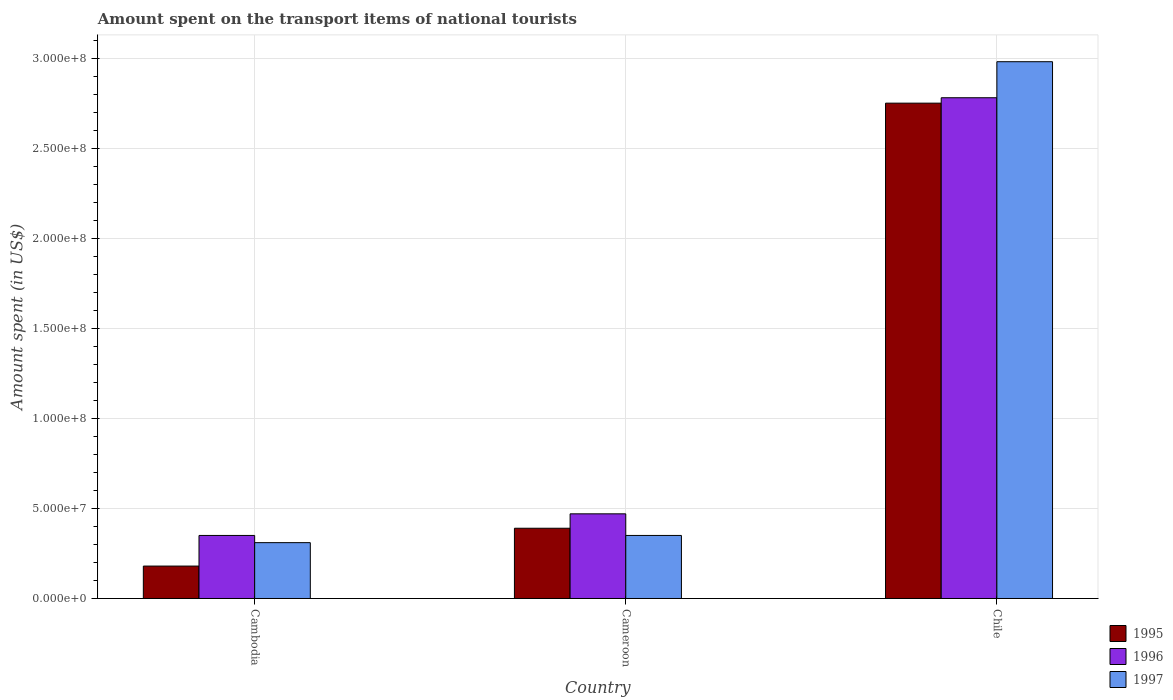How many groups of bars are there?
Offer a terse response. 3. How many bars are there on the 2nd tick from the left?
Offer a very short reply. 3. How many bars are there on the 2nd tick from the right?
Your answer should be very brief. 3. What is the label of the 3rd group of bars from the left?
Ensure brevity in your answer.  Chile. What is the amount spent on the transport items of national tourists in 1996 in Cambodia?
Give a very brief answer. 3.50e+07. Across all countries, what is the maximum amount spent on the transport items of national tourists in 1996?
Your response must be concise. 2.78e+08. Across all countries, what is the minimum amount spent on the transport items of national tourists in 1997?
Make the answer very short. 3.10e+07. In which country was the amount spent on the transport items of national tourists in 1997 minimum?
Provide a succinct answer. Cambodia. What is the total amount spent on the transport items of national tourists in 1997 in the graph?
Make the answer very short. 3.64e+08. What is the difference between the amount spent on the transport items of national tourists in 1997 in Cambodia and that in Chile?
Give a very brief answer. -2.67e+08. What is the difference between the amount spent on the transport items of national tourists in 1996 in Chile and the amount spent on the transport items of national tourists in 1997 in Cameroon?
Your answer should be very brief. 2.43e+08. What is the average amount spent on the transport items of national tourists in 1996 per country?
Keep it short and to the point. 1.20e+08. What is the difference between the amount spent on the transport items of national tourists of/in 1996 and amount spent on the transport items of national tourists of/in 1997 in Chile?
Your response must be concise. -2.00e+07. In how many countries, is the amount spent on the transport items of national tourists in 1996 greater than 110000000 US$?
Offer a terse response. 1. What is the ratio of the amount spent on the transport items of national tourists in 1996 in Cambodia to that in Chile?
Offer a very short reply. 0.13. Is the difference between the amount spent on the transport items of national tourists in 1996 in Cameroon and Chile greater than the difference between the amount spent on the transport items of national tourists in 1997 in Cameroon and Chile?
Your answer should be compact. Yes. What is the difference between the highest and the second highest amount spent on the transport items of national tourists in 1995?
Your answer should be compact. 2.57e+08. What is the difference between the highest and the lowest amount spent on the transport items of national tourists in 1995?
Your answer should be very brief. 2.57e+08. Is the sum of the amount spent on the transport items of national tourists in 1997 in Cambodia and Cameroon greater than the maximum amount spent on the transport items of national tourists in 1995 across all countries?
Provide a short and direct response. No. What does the 3rd bar from the right in Chile represents?
Give a very brief answer. 1995. Is it the case that in every country, the sum of the amount spent on the transport items of national tourists in 1996 and amount spent on the transport items of national tourists in 1995 is greater than the amount spent on the transport items of national tourists in 1997?
Provide a short and direct response. Yes. How many bars are there?
Give a very brief answer. 9. Are all the bars in the graph horizontal?
Provide a succinct answer. No. How many countries are there in the graph?
Offer a terse response. 3. What is the difference between two consecutive major ticks on the Y-axis?
Provide a short and direct response. 5.00e+07. Does the graph contain any zero values?
Your response must be concise. No. How many legend labels are there?
Your answer should be compact. 3. What is the title of the graph?
Your answer should be compact. Amount spent on the transport items of national tourists. What is the label or title of the Y-axis?
Offer a terse response. Amount spent (in US$). What is the Amount spent (in US$) in 1995 in Cambodia?
Offer a terse response. 1.80e+07. What is the Amount spent (in US$) in 1996 in Cambodia?
Provide a succinct answer. 3.50e+07. What is the Amount spent (in US$) of 1997 in Cambodia?
Give a very brief answer. 3.10e+07. What is the Amount spent (in US$) in 1995 in Cameroon?
Offer a terse response. 3.90e+07. What is the Amount spent (in US$) in 1996 in Cameroon?
Ensure brevity in your answer.  4.70e+07. What is the Amount spent (in US$) of 1997 in Cameroon?
Your answer should be compact. 3.50e+07. What is the Amount spent (in US$) in 1995 in Chile?
Provide a short and direct response. 2.75e+08. What is the Amount spent (in US$) of 1996 in Chile?
Your answer should be compact. 2.78e+08. What is the Amount spent (in US$) of 1997 in Chile?
Provide a short and direct response. 2.98e+08. Across all countries, what is the maximum Amount spent (in US$) of 1995?
Ensure brevity in your answer.  2.75e+08. Across all countries, what is the maximum Amount spent (in US$) of 1996?
Provide a succinct answer. 2.78e+08. Across all countries, what is the maximum Amount spent (in US$) in 1997?
Offer a very short reply. 2.98e+08. Across all countries, what is the minimum Amount spent (in US$) in 1995?
Your answer should be compact. 1.80e+07. Across all countries, what is the minimum Amount spent (in US$) in 1996?
Give a very brief answer. 3.50e+07. Across all countries, what is the minimum Amount spent (in US$) of 1997?
Offer a very short reply. 3.10e+07. What is the total Amount spent (in US$) in 1995 in the graph?
Offer a terse response. 3.32e+08. What is the total Amount spent (in US$) of 1996 in the graph?
Your response must be concise. 3.60e+08. What is the total Amount spent (in US$) in 1997 in the graph?
Offer a very short reply. 3.64e+08. What is the difference between the Amount spent (in US$) of 1995 in Cambodia and that in Cameroon?
Give a very brief answer. -2.10e+07. What is the difference between the Amount spent (in US$) in 1996 in Cambodia and that in Cameroon?
Your answer should be compact. -1.20e+07. What is the difference between the Amount spent (in US$) of 1995 in Cambodia and that in Chile?
Make the answer very short. -2.57e+08. What is the difference between the Amount spent (in US$) of 1996 in Cambodia and that in Chile?
Your response must be concise. -2.43e+08. What is the difference between the Amount spent (in US$) of 1997 in Cambodia and that in Chile?
Provide a short and direct response. -2.67e+08. What is the difference between the Amount spent (in US$) of 1995 in Cameroon and that in Chile?
Your answer should be compact. -2.36e+08. What is the difference between the Amount spent (in US$) in 1996 in Cameroon and that in Chile?
Give a very brief answer. -2.31e+08. What is the difference between the Amount spent (in US$) of 1997 in Cameroon and that in Chile?
Provide a short and direct response. -2.63e+08. What is the difference between the Amount spent (in US$) in 1995 in Cambodia and the Amount spent (in US$) in 1996 in Cameroon?
Your answer should be very brief. -2.90e+07. What is the difference between the Amount spent (in US$) of 1995 in Cambodia and the Amount spent (in US$) of 1997 in Cameroon?
Offer a terse response. -1.70e+07. What is the difference between the Amount spent (in US$) in 1995 in Cambodia and the Amount spent (in US$) in 1996 in Chile?
Offer a very short reply. -2.60e+08. What is the difference between the Amount spent (in US$) in 1995 in Cambodia and the Amount spent (in US$) in 1997 in Chile?
Your answer should be very brief. -2.80e+08. What is the difference between the Amount spent (in US$) of 1996 in Cambodia and the Amount spent (in US$) of 1997 in Chile?
Offer a terse response. -2.63e+08. What is the difference between the Amount spent (in US$) of 1995 in Cameroon and the Amount spent (in US$) of 1996 in Chile?
Your response must be concise. -2.39e+08. What is the difference between the Amount spent (in US$) of 1995 in Cameroon and the Amount spent (in US$) of 1997 in Chile?
Provide a short and direct response. -2.59e+08. What is the difference between the Amount spent (in US$) of 1996 in Cameroon and the Amount spent (in US$) of 1997 in Chile?
Offer a very short reply. -2.51e+08. What is the average Amount spent (in US$) in 1995 per country?
Your response must be concise. 1.11e+08. What is the average Amount spent (in US$) of 1996 per country?
Make the answer very short. 1.20e+08. What is the average Amount spent (in US$) of 1997 per country?
Make the answer very short. 1.21e+08. What is the difference between the Amount spent (in US$) of 1995 and Amount spent (in US$) of 1996 in Cambodia?
Keep it short and to the point. -1.70e+07. What is the difference between the Amount spent (in US$) in 1995 and Amount spent (in US$) in 1997 in Cambodia?
Offer a very short reply. -1.30e+07. What is the difference between the Amount spent (in US$) of 1995 and Amount spent (in US$) of 1996 in Cameroon?
Ensure brevity in your answer.  -8.00e+06. What is the difference between the Amount spent (in US$) of 1995 and Amount spent (in US$) of 1997 in Cameroon?
Provide a succinct answer. 4.00e+06. What is the difference between the Amount spent (in US$) of 1996 and Amount spent (in US$) of 1997 in Cameroon?
Offer a very short reply. 1.20e+07. What is the difference between the Amount spent (in US$) of 1995 and Amount spent (in US$) of 1997 in Chile?
Provide a succinct answer. -2.30e+07. What is the difference between the Amount spent (in US$) of 1996 and Amount spent (in US$) of 1997 in Chile?
Provide a short and direct response. -2.00e+07. What is the ratio of the Amount spent (in US$) in 1995 in Cambodia to that in Cameroon?
Keep it short and to the point. 0.46. What is the ratio of the Amount spent (in US$) in 1996 in Cambodia to that in Cameroon?
Give a very brief answer. 0.74. What is the ratio of the Amount spent (in US$) of 1997 in Cambodia to that in Cameroon?
Keep it short and to the point. 0.89. What is the ratio of the Amount spent (in US$) in 1995 in Cambodia to that in Chile?
Offer a very short reply. 0.07. What is the ratio of the Amount spent (in US$) of 1996 in Cambodia to that in Chile?
Make the answer very short. 0.13. What is the ratio of the Amount spent (in US$) of 1997 in Cambodia to that in Chile?
Provide a short and direct response. 0.1. What is the ratio of the Amount spent (in US$) in 1995 in Cameroon to that in Chile?
Offer a very short reply. 0.14. What is the ratio of the Amount spent (in US$) of 1996 in Cameroon to that in Chile?
Give a very brief answer. 0.17. What is the ratio of the Amount spent (in US$) of 1997 in Cameroon to that in Chile?
Provide a succinct answer. 0.12. What is the difference between the highest and the second highest Amount spent (in US$) in 1995?
Provide a succinct answer. 2.36e+08. What is the difference between the highest and the second highest Amount spent (in US$) in 1996?
Keep it short and to the point. 2.31e+08. What is the difference between the highest and the second highest Amount spent (in US$) of 1997?
Keep it short and to the point. 2.63e+08. What is the difference between the highest and the lowest Amount spent (in US$) in 1995?
Your response must be concise. 2.57e+08. What is the difference between the highest and the lowest Amount spent (in US$) in 1996?
Keep it short and to the point. 2.43e+08. What is the difference between the highest and the lowest Amount spent (in US$) in 1997?
Keep it short and to the point. 2.67e+08. 